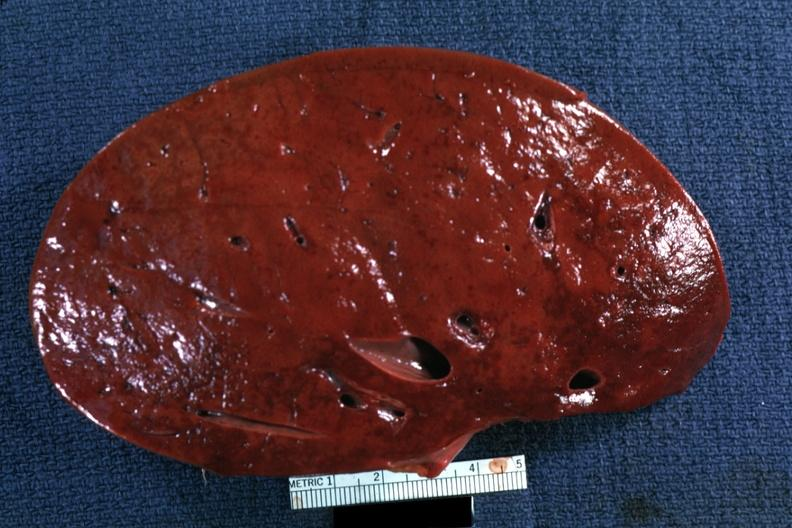s inflamed exocervix present?
Answer the question using a single word or phrase. No 